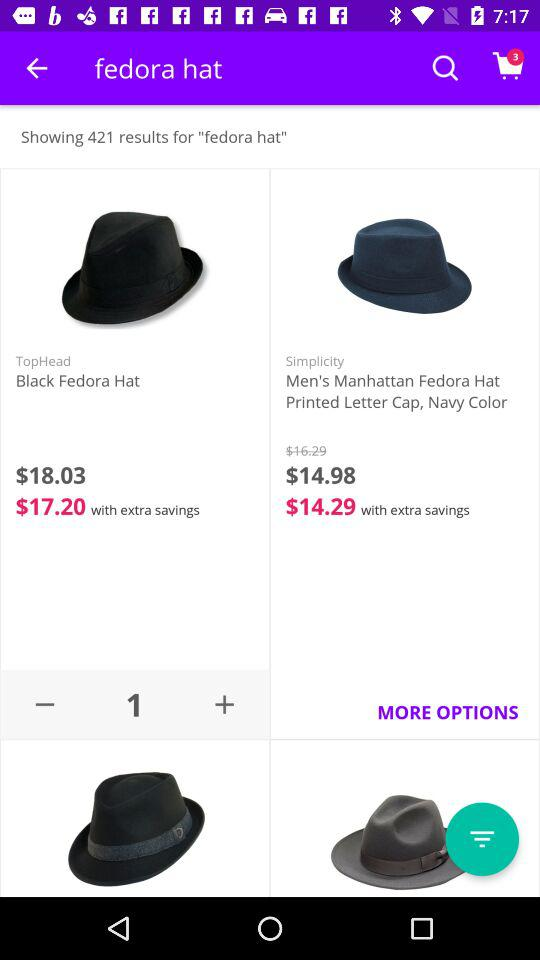How many items named "Black Fedora Hat" are added to the shopping cart? There is 1 item named "Black Fedora Hat". 